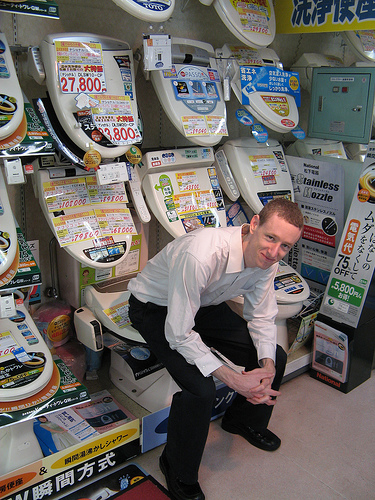Who is wearing trousers? The boy in the image is wearing trousers, pairing them with a neat white dress shirt. 